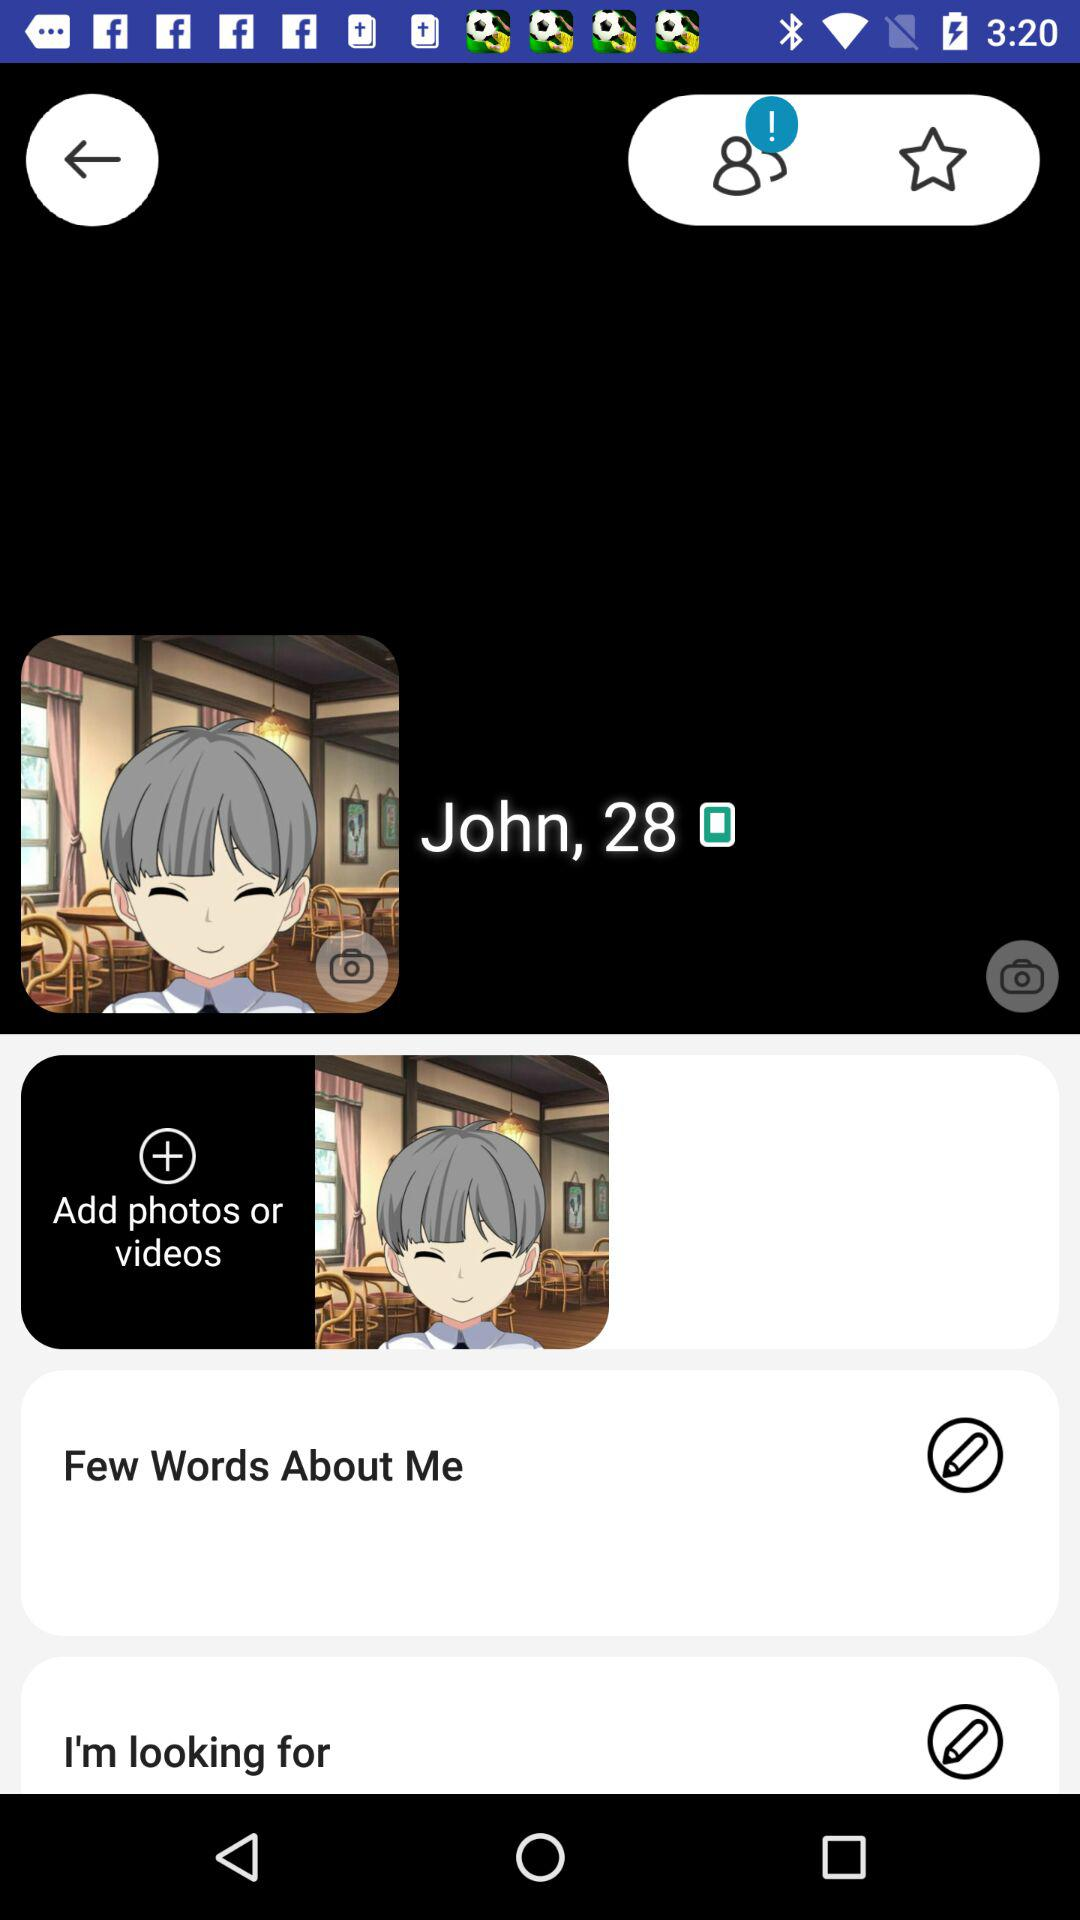What is the name shown on the screen? The name shown on the screen is John. 